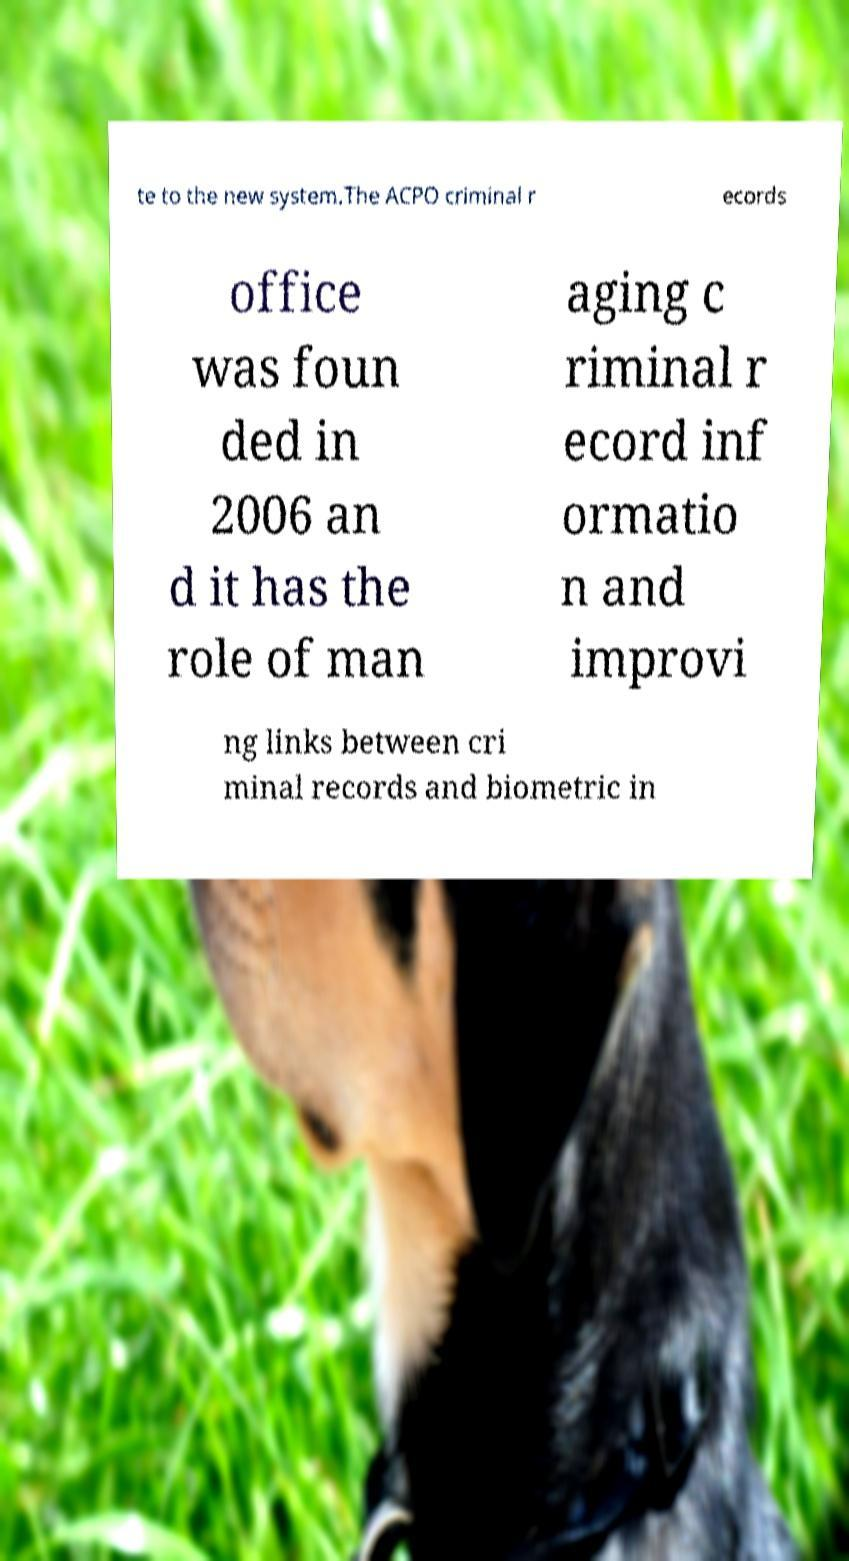For documentation purposes, I need the text within this image transcribed. Could you provide that? te to the new system.The ACPO criminal r ecords office was foun ded in 2006 an d it has the role of man aging c riminal r ecord inf ormatio n and improvi ng links between cri minal records and biometric in 